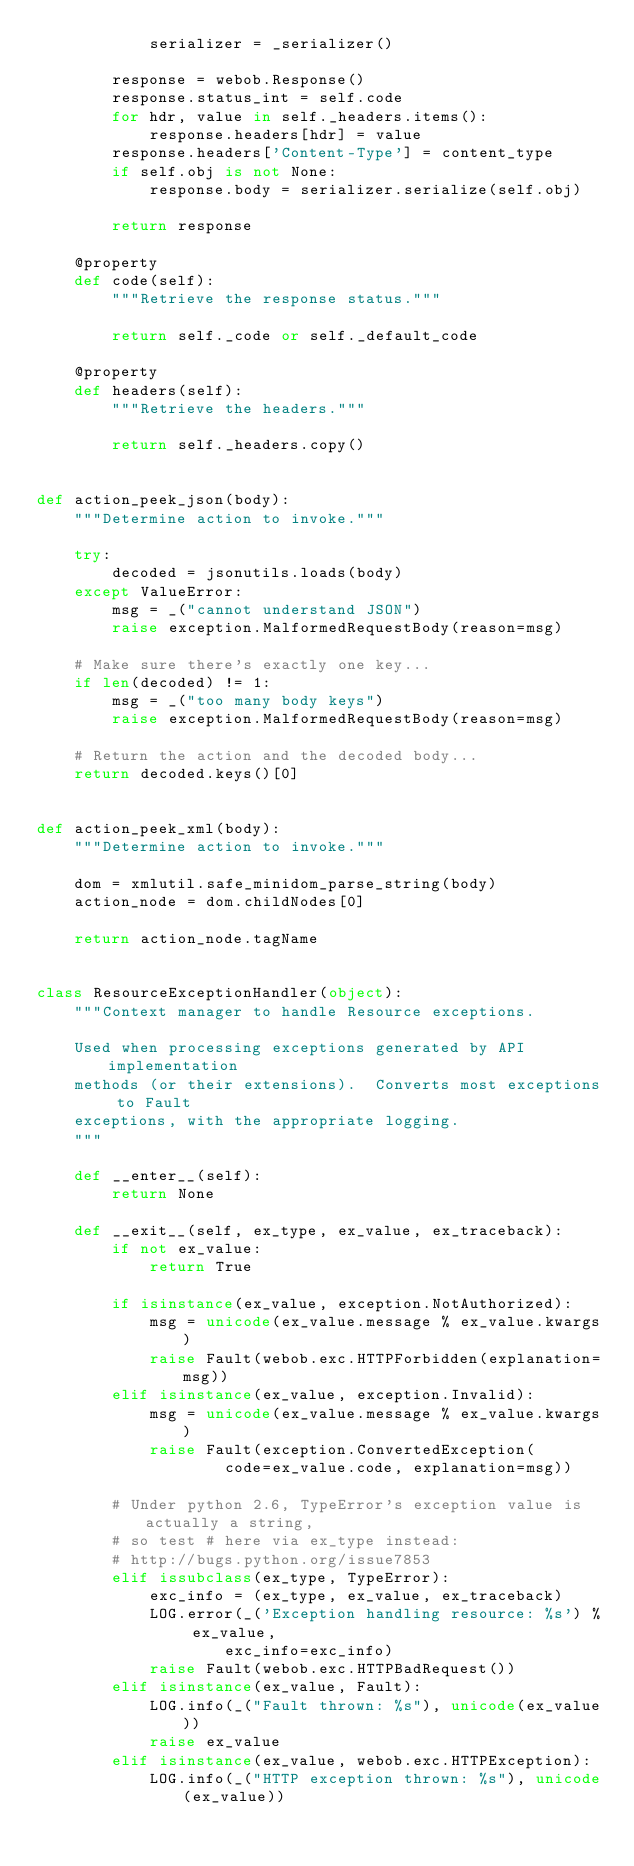Convert code to text. <code><loc_0><loc_0><loc_500><loc_500><_Python_>            serializer = _serializer()

        response = webob.Response()
        response.status_int = self.code
        for hdr, value in self._headers.items():
            response.headers[hdr] = value
        response.headers['Content-Type'] = content_type
        if self.obj is not None:
            response.body = serializer.serialize(self.obj)

        return response

    @property
    def code(self):
        """Retrieve the response status."""

        return self._code or self._default_code

    @property
    def headers(self):
        """Retrieve the headers."""

        return self._headers.copy()


def action_peek_json(body):
    """Determine action to invoke."""

    try:
        decoded = jsonutils.loads(body)
    except ValueError:
        msg = _("cannot understand JSON")
        raise exception.MalformedRequestBody(reason=msg)

    # Make sure there's exactly one key...
    if len(decoded) != 1:
        msg = _("too many body keys")
        raise exception.MalformedRequestBody(reason=msg)

    # Return the action and the decoded body...
    return decoded.keys()[0]


def action_peek_xml(body):
    """Determine action to invoke."""

    dom = xmlutil.safe_minidom_parse_string(body)
    action_node = dom.childNodes[0]

    return action_node.tagName


class ResourceExceptionHandler(object):
    """Context manager to handle Resource exceptions.

    Used when processing exceptions generated by API implementation
    methods (or their extensions).  Converts most exceptions to Fault
    exceptions, with the appropriate logging.
    """

    def __enter__(self):
        return None

    def __exit__(self, ex_type, ex_value, ex_traceback):
        if not ex_value:
            return True

        if isinstance(ex_value, exception.NotAuthorized):
            msg = unicode(ex_value.message % ex_value.kwargs)
            raise Fault(webob.exc.HTTPForbidden(explanation=msg))
        elif isinstance(ex_value, exception.Invalid):
            msg = unicode(ex_value.message % ex_value.kwargs)
            raise Fault(exception.ConvertedException(
                    code=ex_value.code, explanation=msg))

        # Under python 2.6, TypeError's exception value is actually a string,
        # so test # here via ex_type instead:
        # http://bugs.python.org/issue7853
        elif issubclass(ex_type, TypeError):
            exc_info = (ex_type, ex_value, ex_traceback)
            LOG.error(_('Exception handling resource: %s') % ex_value,
                    exc_info=exc_info)
            raise Fault(webob.exc.HTTPBadRequest())
        elif isinstance(ex_value, Fault):
            LOG.info(_("Fault thrown: %s"), unicode(ex_value))
            raise ex_value
        elif isinstance(ex_value, webob.exc.HTTPException):
            LOG.info(_("HTTP exception thrown: %s"), unicode(ex_value))</code> 